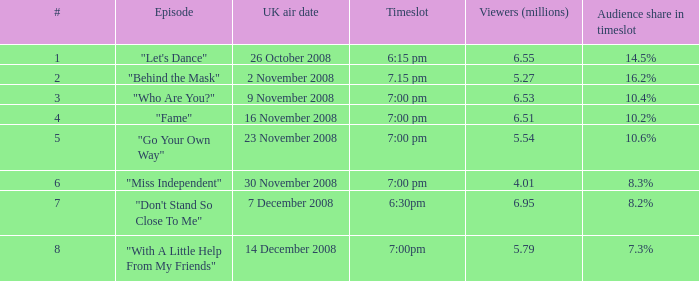Identify the maximum number of viewers considering it as 6.95. 7.0. 